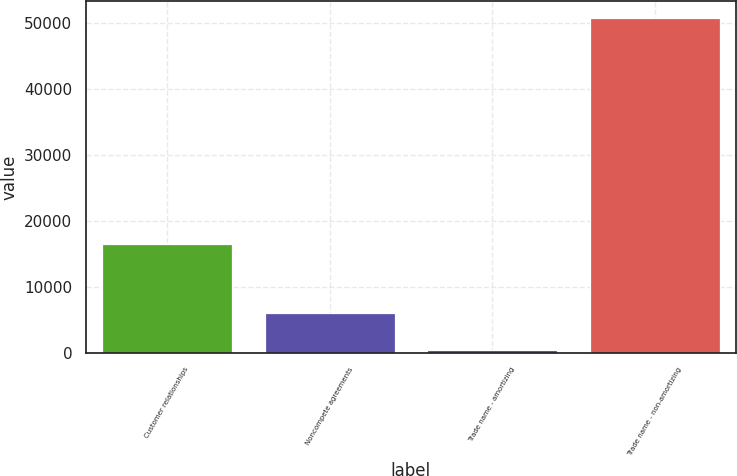Convert chart. <chart><loc_0><loc_0><loc_500><loc_500><bar_chart><fcel>Customer relationships<fcel>Noncompete agreements<fcel>Trade name - amortizing<fcel>Trade name - non-amortizing<nl><fcel>16510<fcel>6069<fcel>455<fcel>50769<nl></chart> 